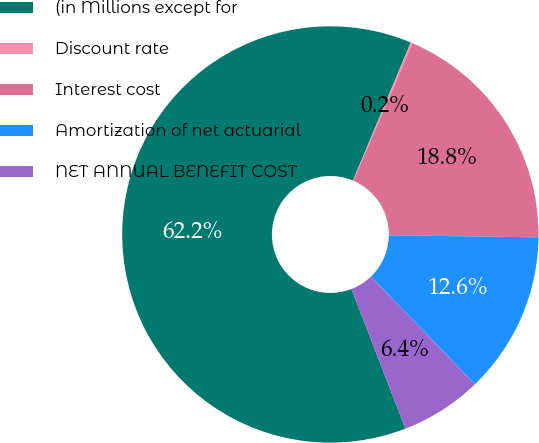Convert chart. <chart><loc_0><loc_0><loc_500><loc_500><pie_chart><fcel>(in Millions except for<fcel>Discount rate<fcel>Interest cost<fcel>Amortization of net actuarial<fcel>NET ANNUAL BENEFIT COST<nl><fcel>62.18%<fcel>0.15%<fcel>18.76%<fcel>12.56%<fcel>6.35%<nl></chart> 